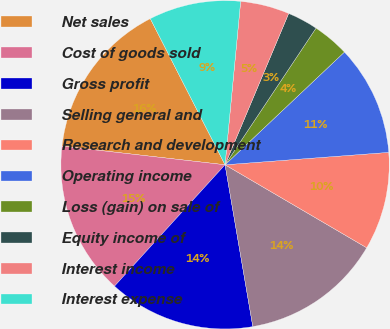<chart> <loc_0><loc_0><loc_500><loc_500><pie_chart><fcel>Net sales<fcel>Cost of goods sold<fcel>Gross profit<fcel>Selling general and<fcel>Research and development<fcel>Operating income<fcel>Loss (gain) on sale of<fcel>Equity income of<fcel>Interest income<fcel>Interest expense<nl><fcel>15.66%<fcel>15.06%<fcel>14.46%<fcel>13.86%<fcel>9.64%<fcel>10.84%<fcel>3.61%<fcel>3.01%<fcel>4.82%<fcel>9.04%<nl></chart> 